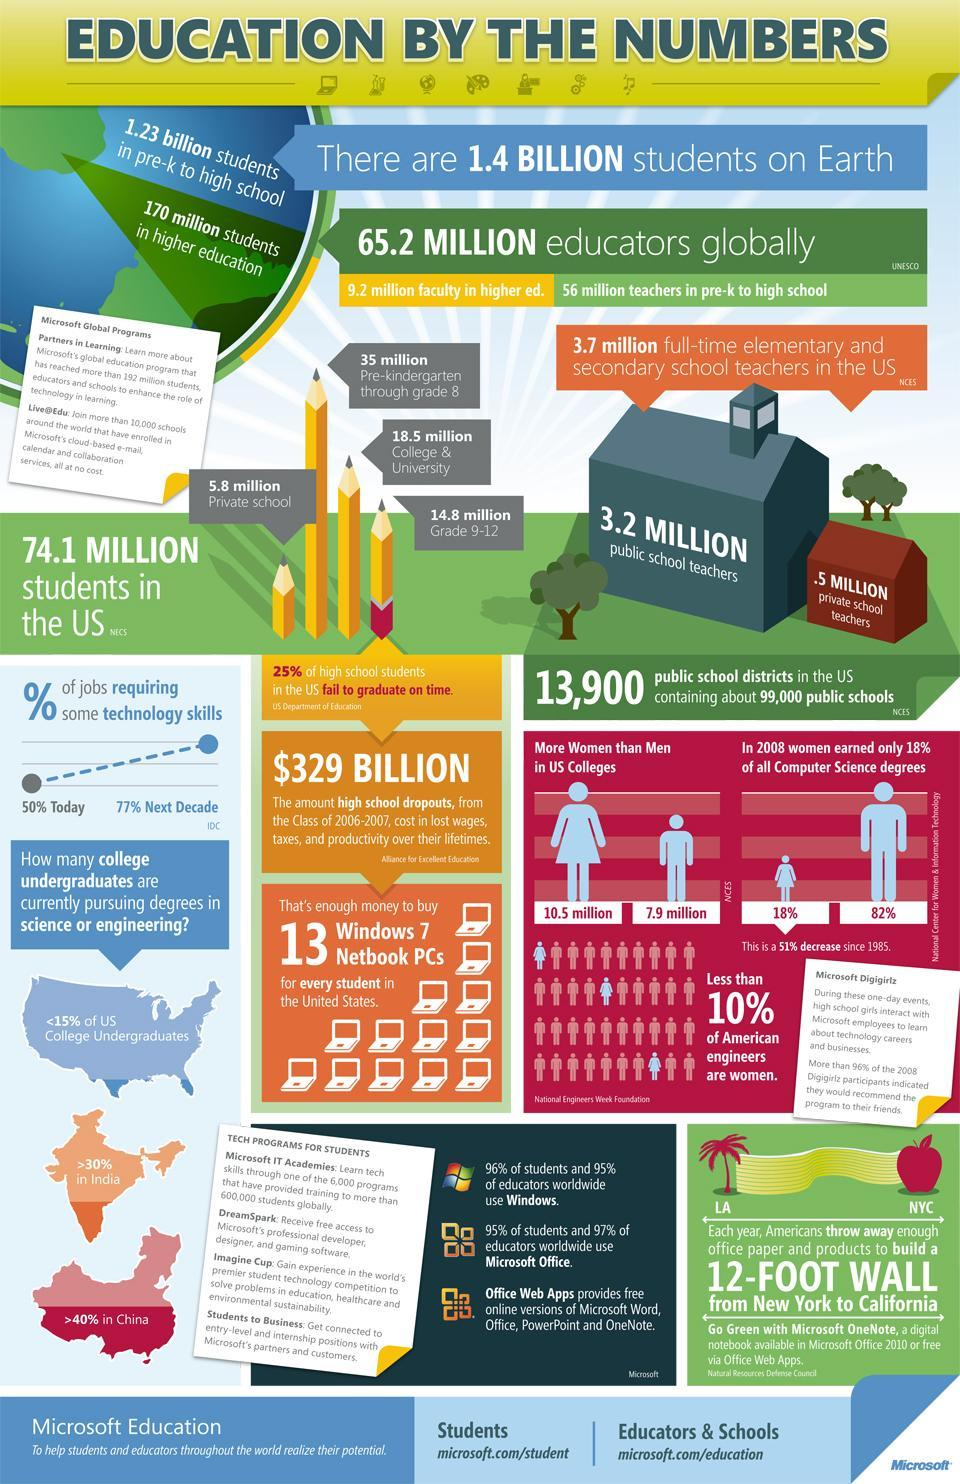What is the population of men in US colleges in 2008?
Answer the question with a short phrase. 7.9 million What percentage of the college undergraduates are currently pursuing degrees in science or engineering in India? >30% What is the women population in US colleges in 2008? 10.5 million What percentage of all computer science degrees are earned by men in the U.S in 2008? 82% 